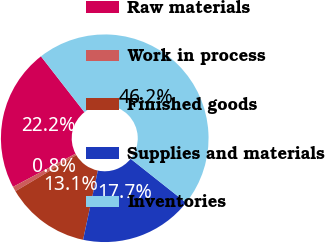Convert chart to OTSL. <chart><loc_0><loc_0><loc_500><loc_500><pie_chart><fcel>Raw materials<fcel>Work in process<fcel>Finished goods<fcel>Supplies and materials<fcel>Inventories<nl><fcel>22.23%<fcel>0.76%<fcel>13.14%<fcel>17.68%<fcel>46.18%<nl></chart> 